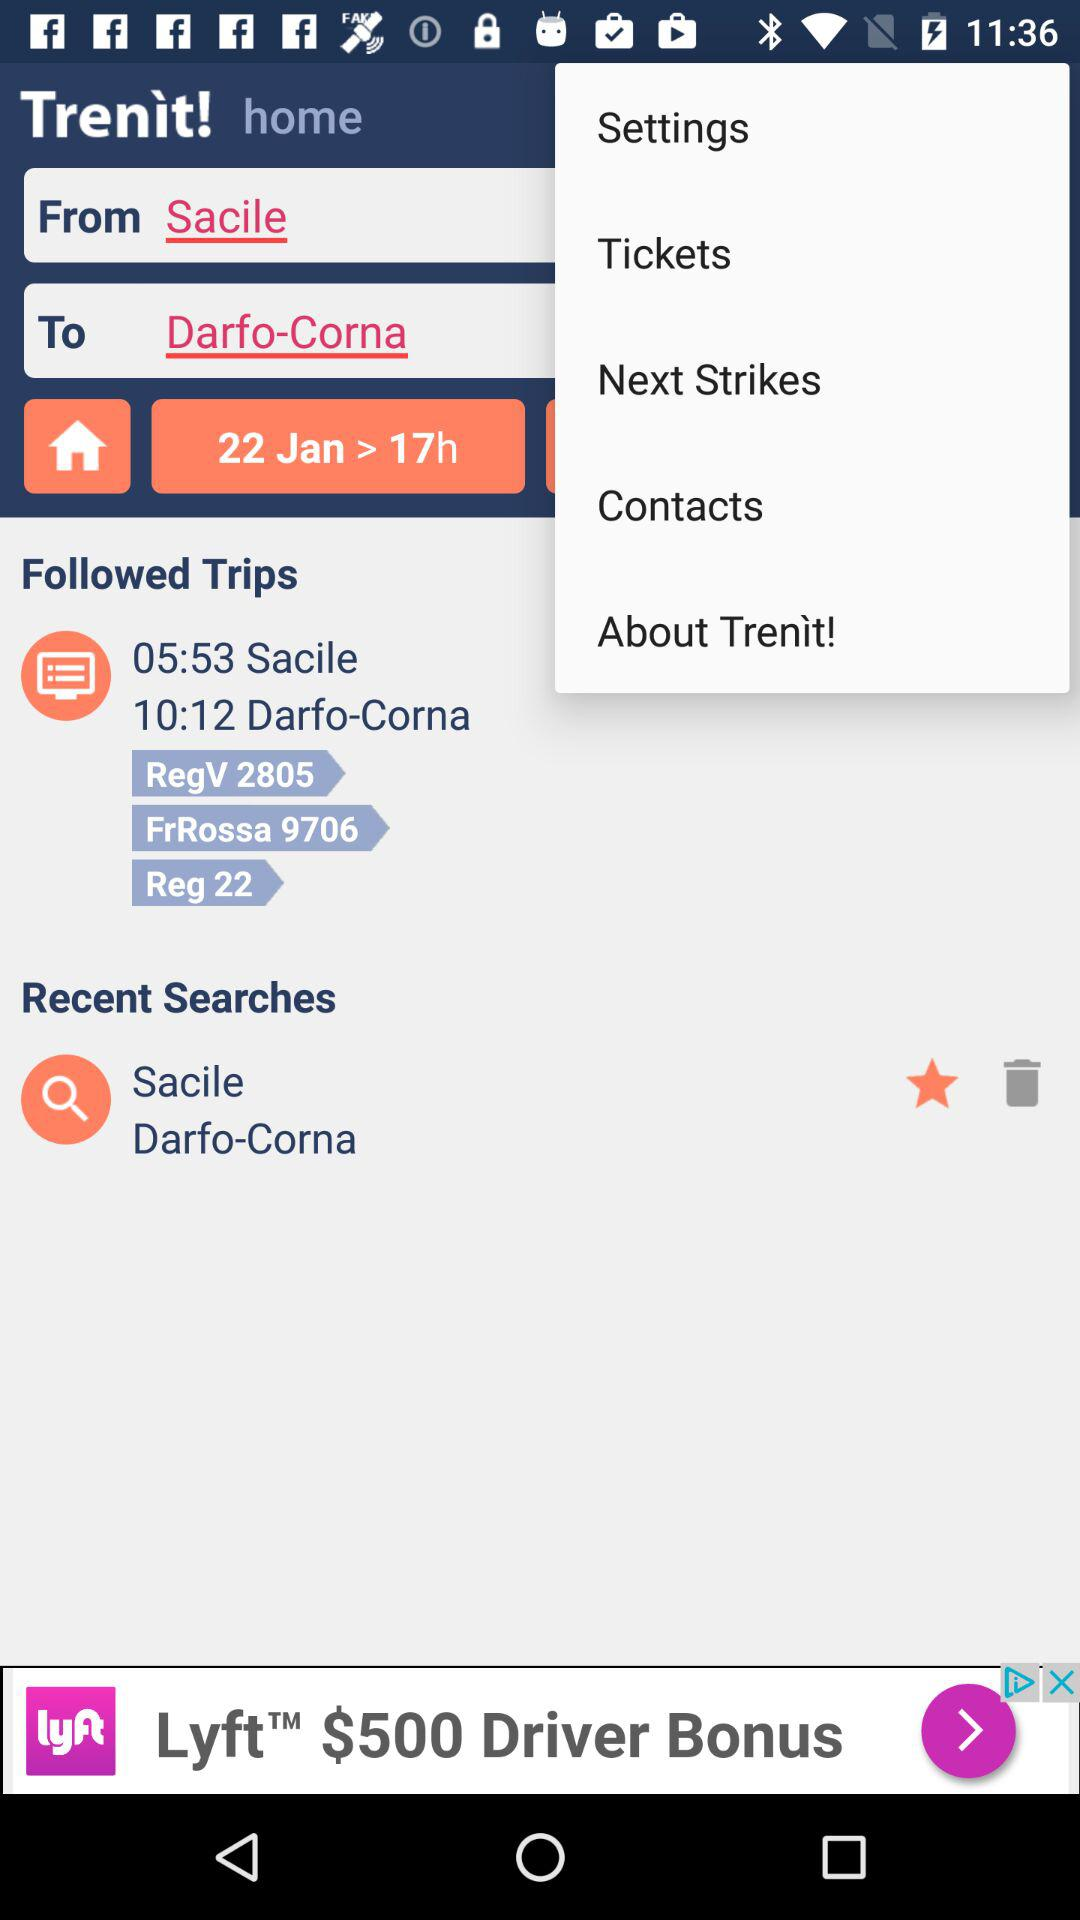What's the departing location name? The departing location name is Sacile. 